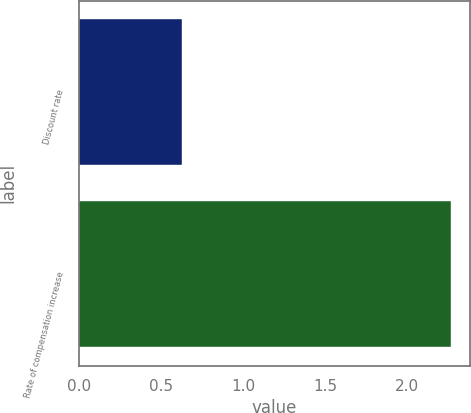Convert chart to OTSL. <chart><loc_0><loc_0><loc_500><loc_500><bar_chart><fcel>Discount rate<fcel>Rate of compensation increase<nl><fcel>0.63<fcel>2.27<nl></chart> 